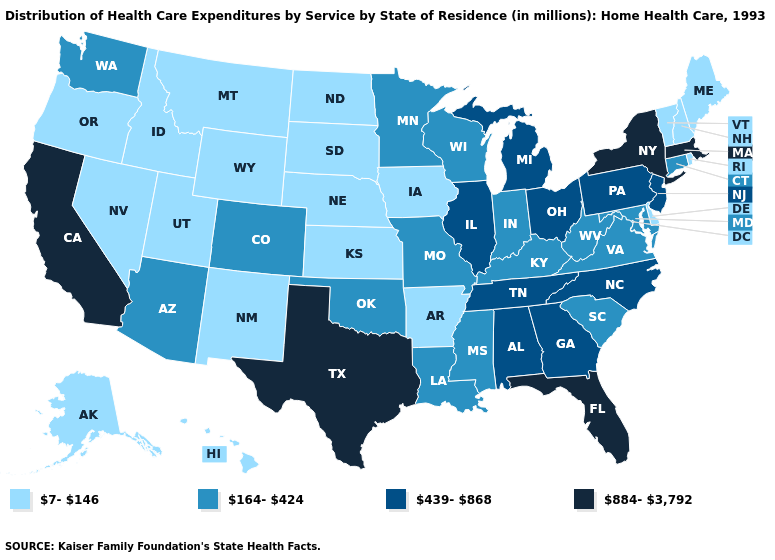What is the lowest value in states that border Delaware?
Quick response, please. 164-424. Name the states that have a value in the range 884-3,792?
Keep it brief. California, Florida, Massachusetts, New York, Texas. What is the lowest value in the USA?
Give a very brief answer. 7-146. What is the highest value in the South ?
Keep it brief. 884-3,792. Name the states that have a value in the range 439-868?
Give a very brief answer. Alabama, Georgia, Illinois, Michigan, New Jersey, North Carolina, Ohio, Pennsylvania, Tennessee. Does Florida have the highest value in the South?
Be succinct. Yes. What is the highest value in states that border Iowa?
Quick response, please. 439-868. What is the value of Arizona?
Answer briefly. 164-424. What is the highest value in the USA?
Short answer required. 884-3,792. What is the value of Connecticut?
Concise answer only. 164-424. What is the value of New Hampshire?
Short answer required. 7-146. What is the highest value in states that border Missouri?
Write a very short answer. 439-868. Among the states that border Oregon , which have the lowest value?
Keep it brief. Idaho, Nevada. What is the highest value in states that border Montana?
Concise answer only. 7-146. 